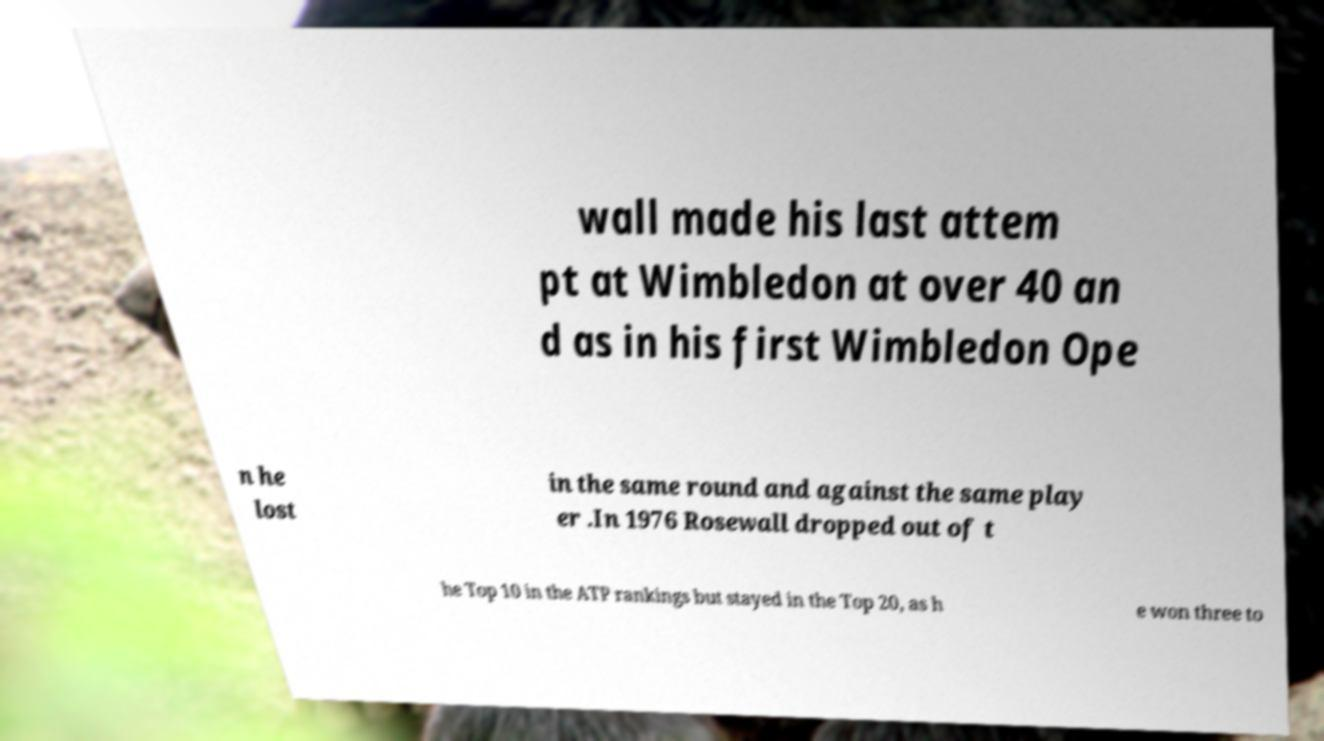Can you read and provide the text displayed in the image?This photo seems to have some interesting text. Can you extract and type it out for me? wall made his last attem pt at Wimbledon at over 40 an d as in his first Wimbledon Ope n he lost in the same round and against the same play er .In 1976 Rosewall dropped out of t he Top 10 in the ATP rankings but stayed in the Top 20, as h e won three to 